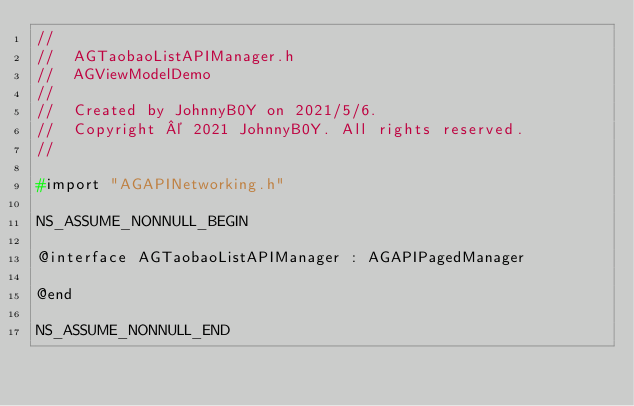<code> <loc_0><loc_0><loc_500><loc_500><_C_>//
//  AGTaobaoListAPIManager.h
//  AGViewModelDemo
//
//  Created by JohnnyB0Y on 2021/5/6.
//  Copyright © 2021 JohnnyB0Y. All rights reserved.
//

#import "AGAPINetworking.h"

NS_ASSUME_NONNULL_BEGIN

@interface AGTaobaoListAPIManager : AGAPIPagedManager

@end

NS_ASSUME_NONNULL_END
</code> 